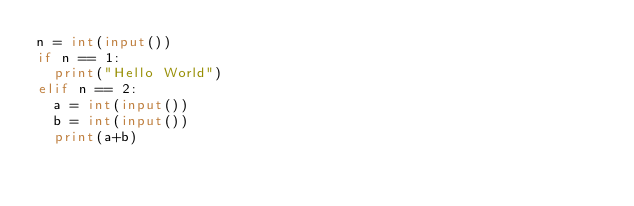Convert code to text. <code><loc_0><loc_0><loc_500><loc_500><_Python_>n = int(input())
if n == 1:
  print("Hello World")
elif n == 2:
  a = int(input())
  b = int(input())
  print(a+b)</code> 